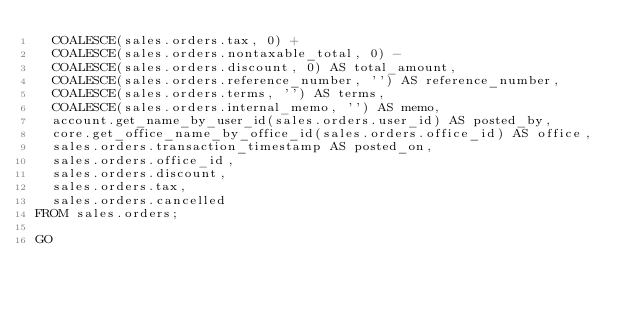<code> <loc_0><loc_0><loc_500><loc_500><_SQL_>	COALESCE(sales.orders.tax, 0) + 
	COALESCE(sales.orders.nontaxable_total, 0) - 
	COALESCE(sales.orders.discount, 0) AS total_amount,
	COALESCE(sales.orders.reference_number, '') AS reference_number,
	COALESCE(sales.orders.terms, '') AS terms,
	COALESCE(sales.orders.internal_memo, '') AS memo,
	account.get_name_by_user_id(sales.orders.user_id) AS posted_by,
	core.get_office_name_by_office_id(sales.orders.office_id) AS office,
	sales.orders.transaction_timestamp AS posted_on,
	sales.orders.office_id,
	sales.orders.discount,
	sales.orders.tax,
	sales.orders.cancelled
FROM sales.orders;

GO
</code> 